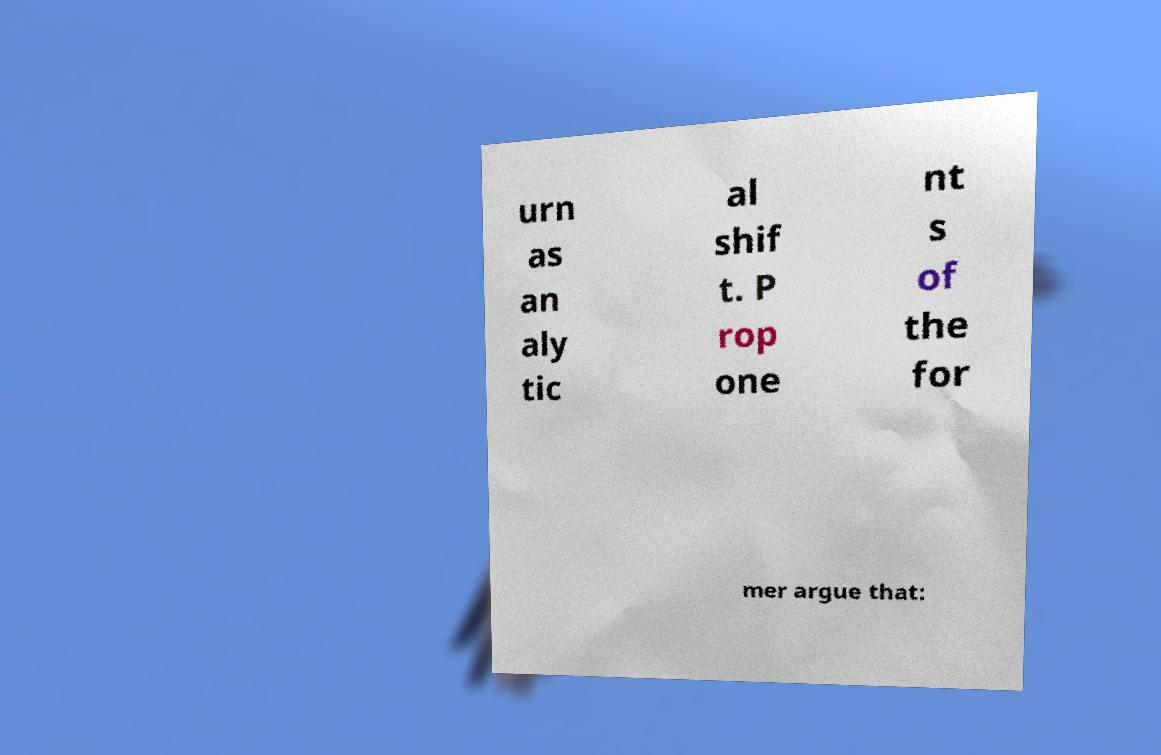Can you read and provide the text displayed in the image?This photo seems to have some interesting text. Can you extract and type it out for me? urn as an aly tic al shif t. P rop one nt s of the for mer argue that: 